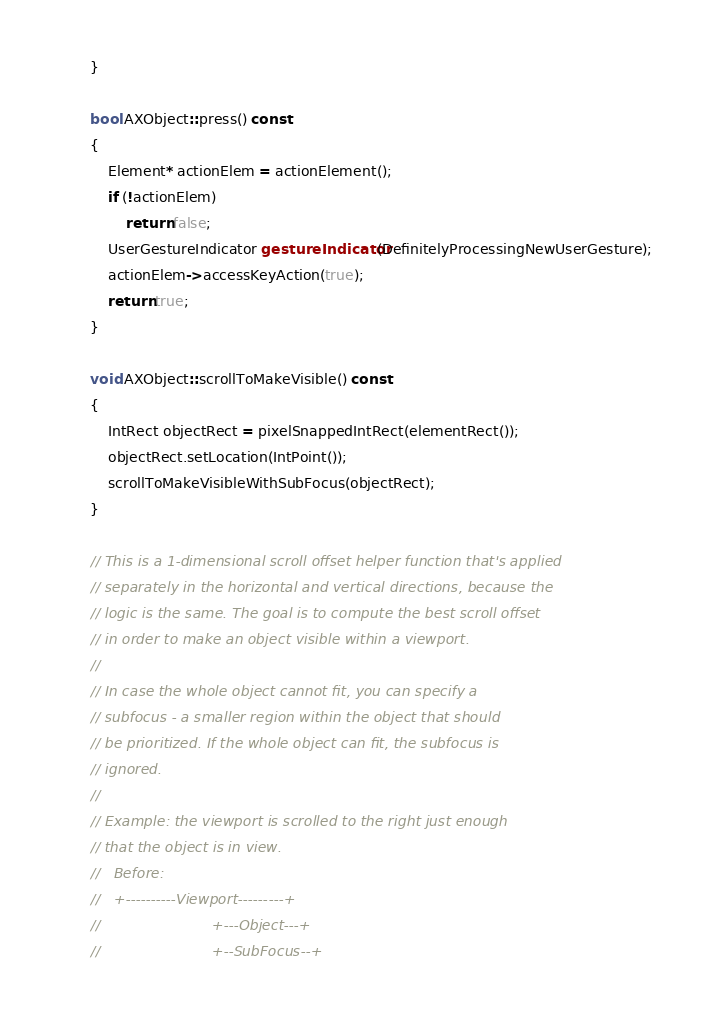<code> <loc_0><loc_0><loc_500><loc_500><_C++_>}

bool AXObject::press() const
{
    Element* actionElem = actionElement();
    if (!actionElem)
        return false;
    UserGestureIndicator gestureIndicator(DefinitelyProcessingNewUserGesture);
    actionElem->accessKeyAction(true);
    return true;
}

void AXObject::scrollToMakeVisible() const
{
    IntRect objectRect = pixelSnappedIntRect(elementRect());
    objectRect.setLocation(IntPoint());
    scrollToMakeVisibleWithSubFocus(objectRect);
}

// This is a 1-dimensional scroll offset helper function that's applied
// separately in the horizontal and vertical directions, because the
// logic is the same. The goal is to compute the best scroll offset
// in order to make an object visible within a viewport.
//
// In case the whole object cannot fit, you can specify a
// subfocus - a smaller region within the object that should
// be prioritized. If the whole object can fit, the subfocus is
// ignored.
//
// Example: the viewport is scrolled to the right just enough
// that the object is in view.
//   Before:
//   +----------Viewport---------+
//                         +---Object---+
//                         +--SubFocus--+</code> 